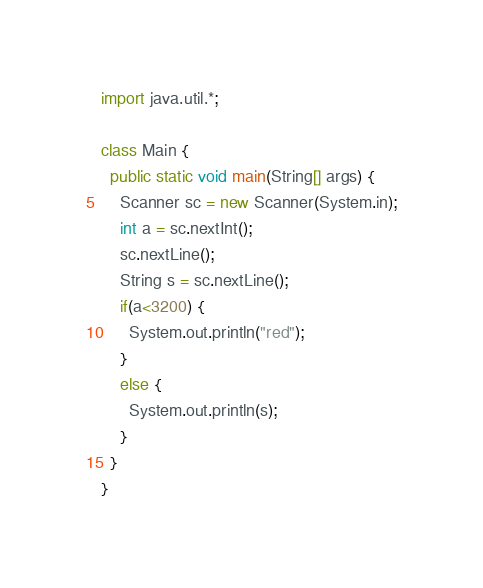Convert code to text. <code><loc_0><loc_0><loc_500><loc_500><_Java_>import java.util.*;

class Main {
  public static void main(String[] args) {
    Scanner sc = new Scanner(System.in);
    int a = sc.nextInt();
    sc.nextLine();
    String s = sc.nextLine();
    if(a<3200) {
      System.out.println("red");
    }
    else {
      System.out.println(s);
    }
  }
}</code> 